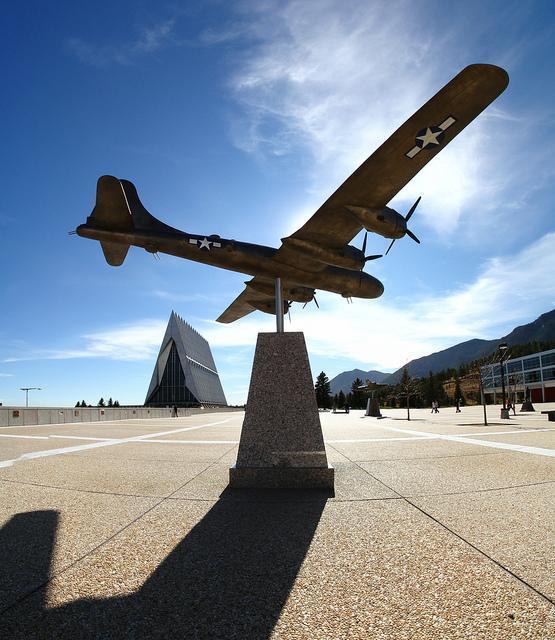How many airplanes can be seen?
Give a very brief answer. 1. How many cars are facing away from the camera?
Give a very brief answer. 0. 